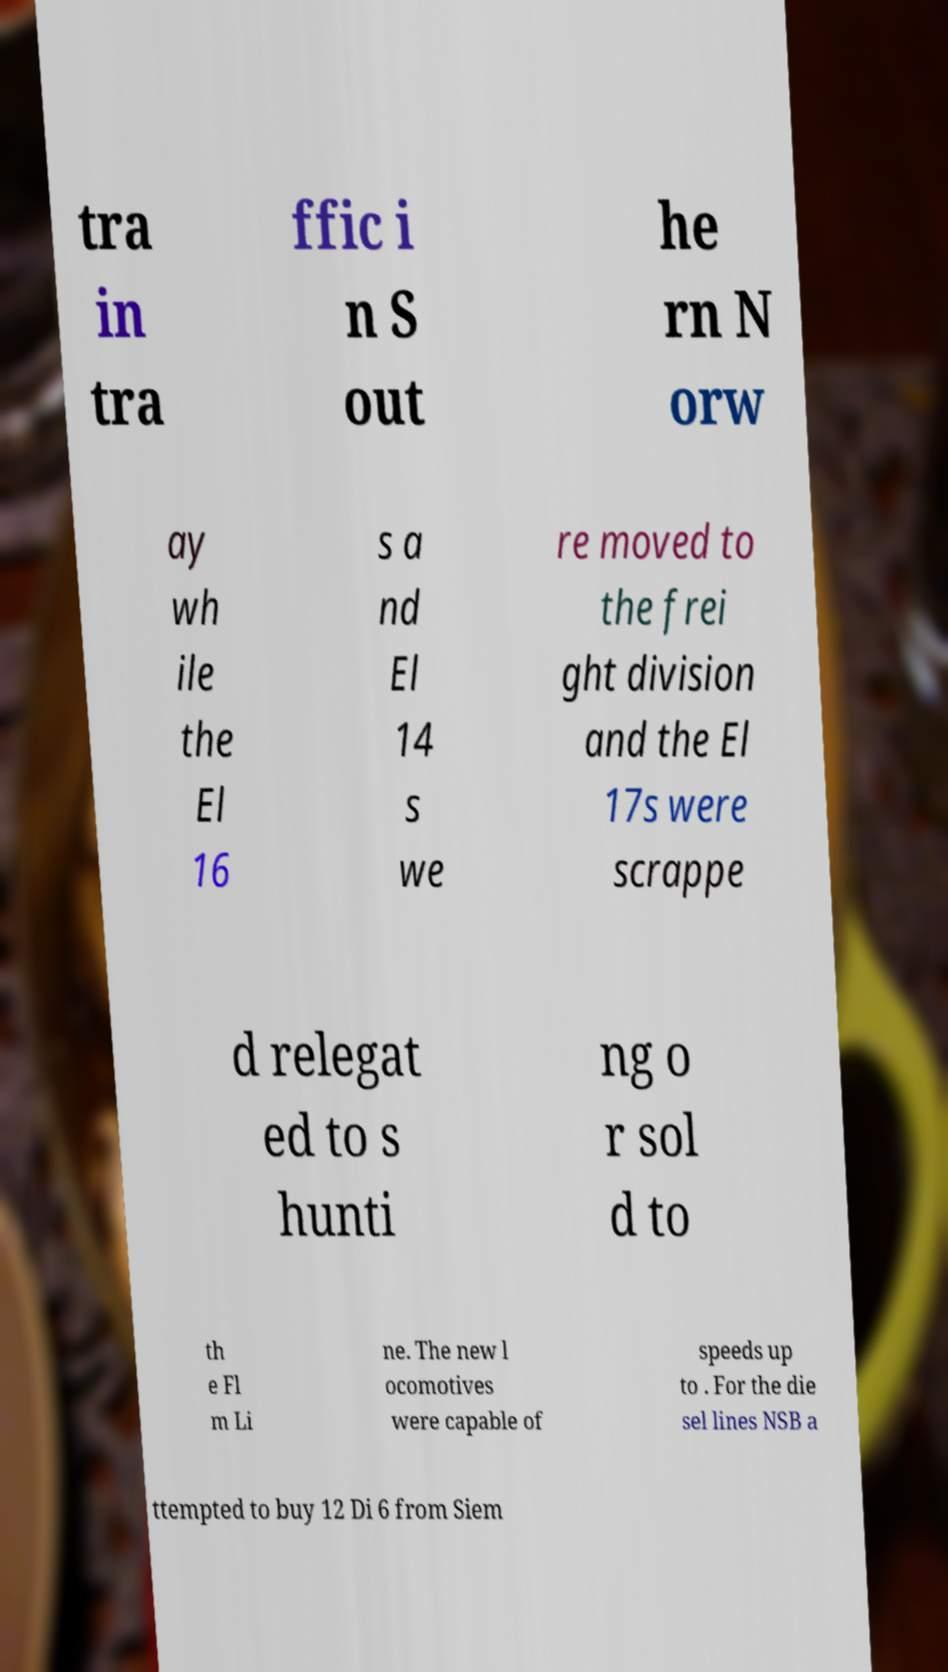For documentation purposes, I need the text within this image transcribed. Could you provide that? tra in tra ffic i n S out he rn N orw ay wh ile the El 16 s a nd El 14 s we re moved to the frei ght division and the El 17s were scrappe d relegat ed to s hunti ng o r sol d to th e Fl m Li ne. The new l ocomotives were capable of speeds up to . For the die sel lines NSB a ttempted to buy 12 Di 6 from Siem 